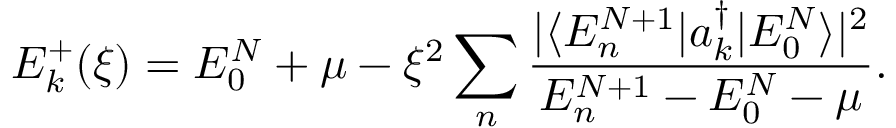Convert formula to latex. <formula><loc_0><loc_0><loc_500><loc_500>E _ { k } ^ { + } ( \xi ) = E _ { 0 } ^ { N } + \mu - \xi ^ { 2 } \sum _ { n } \frac { | \langle E _ { n } ^ { N + 1 } | a _ { k } ^ { \dagger } | E _ { 0 } ^ { N } \rangle | ^ { 2 } } { E _ { n } ^ { N + 1 } - E _ { 0 } ^ { N } - \mu } .</formula> 